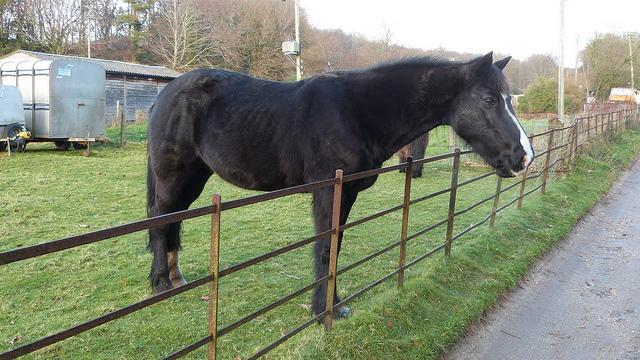Is this a male horse?
Short answer required. No. What type of structure is behind the horse?
Concise answer only. Barn. What is the color of the animal?
Short answer required. Black. What is the material across the top of the fence?
Keep it brief. Metal. Is the horse trying to jump over the fence?
Keep it brief. No. What animal is this?
Give a very brief answer. Horse. Is one of the horses wearing a hat?
Write a very short answer. No. 